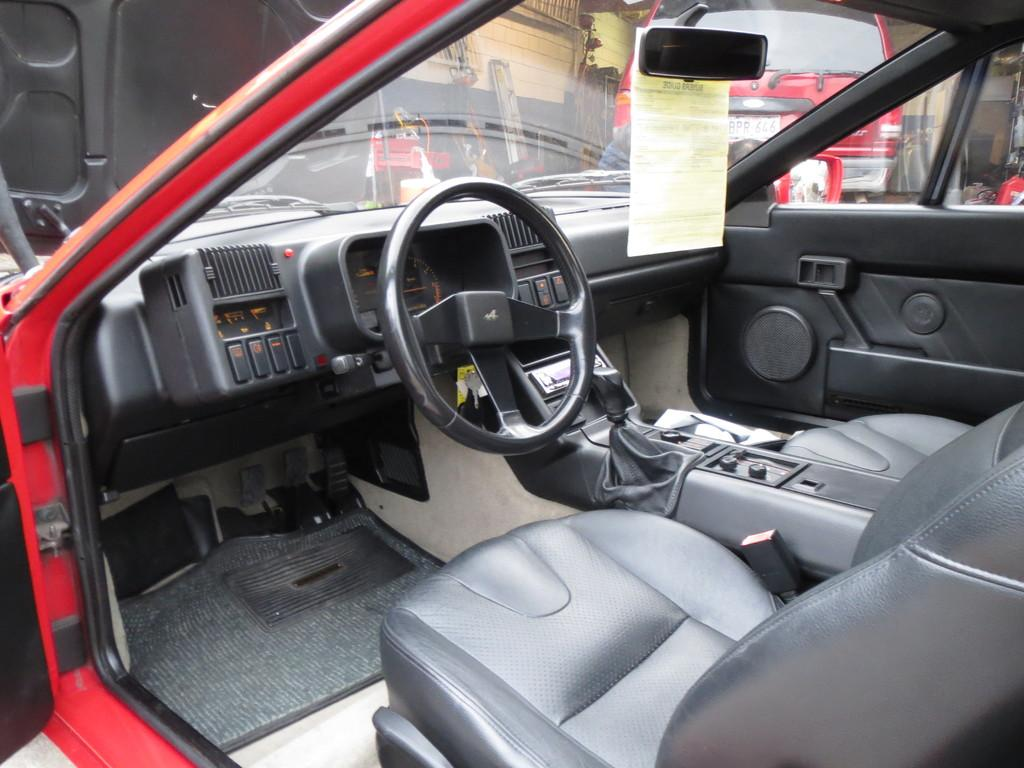What types of objects are present in the image? There are vehicles in the image, including an inside view of a car. Can you describe the interior of the car in the image? The inside view of the car shows a paper visible in the image. What else can be seen in the image besides the car? There are no other objects mentioned in the provided facts. How many sheep can be seen grazing in the image? There are no sheep present in the image. What type of cats are visible in the image? There are no cats present in the image. 